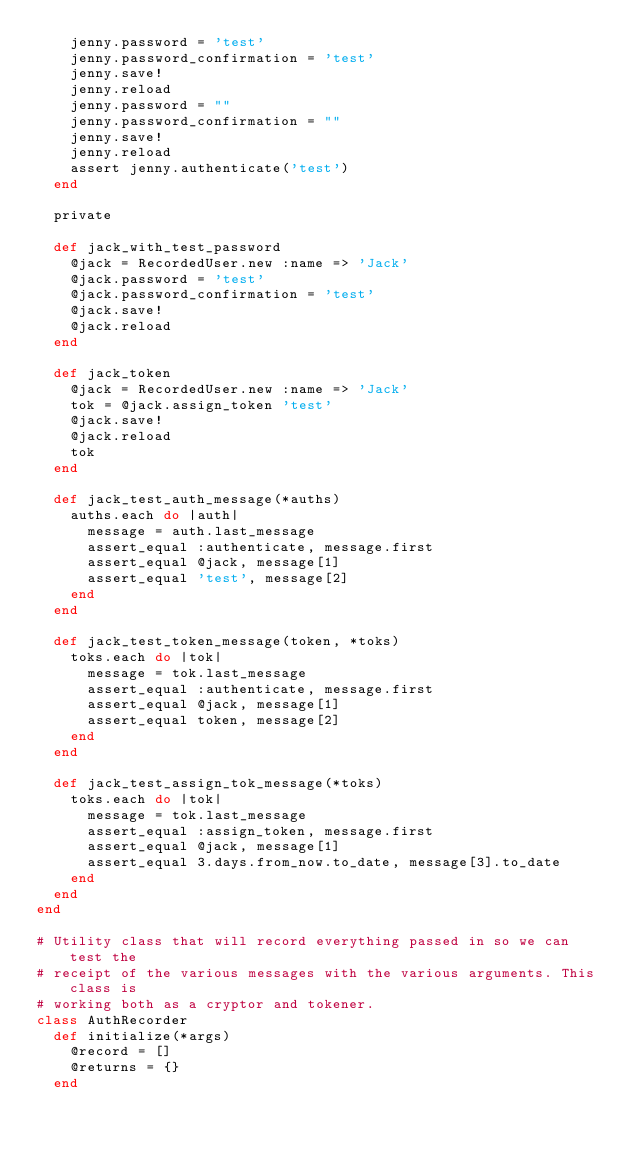<code> <loc_0><loc_0><loc_500><loc_500><_Ruby_>    jenny.password = 'test'
    jenny.password_confirmation = 'test'
    jenny.save!
    jenny.reload
    jenny.password = ""
    jenny.password_confirmation = ""
    jenny.save!
    jenny.reload
    assert jenny.authenticate('test')
  end

  private

  def jack_with_test_password
    @jack = RecordedUser.new :name => 'Jack'
    @jack.password = 'test'
    @jack.password_confirmation = 'test'
    @jack.save!
    @jack.reload
  end

  def jack_token
    @jack = RecordedUser.new :name => 'Jack'
    tok = @jack.assign_token 'test'
    @jack.save!
    @jack.reload
    tok
  end

  def jack_test_auth_message(*auths)
    auths.each do |auth|
      message = auth.last_message
      assert_equal :authenticate, message.first
      assert_equal @jack, message[1]
      assert_equal 'test', message[2]
    end
  end

  def jack_test_token_message(token, *toks)
    toks.each do |tok|
      message = tok.last_message
      assert_equal :authenticate, message.first
      assert_equal @jack, message[1]
      assert_equal token, message[2]
    end
  end

  def jack_test_assign_tok_message(*toks)
    toks.each do |tok|
      message = tok.last_message
      assert_equal :assign_token, message.first
      assert_equal @jack, message[1]
      assert_equal 3.days.from_now.to_date, message[3].to_date
    end
  end
end

# Utility class that will record everything passed in so we can test the
# receipt of the various messages with the various arguments. This class is
# working both as a cryptor and tokener.
class AuthRecorder
  def initialize(*args)
    @record = []
    @returns = {}
  end</code> 